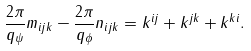<formula> <loc_0><loc_0><loc_500><loc_500>\frac { 2 \pi } { q _ { \psi } } m _ { i j k } - \frac { 2 \pi } { q _ { \phi } } n _ { i j k } = k ^ { i j } + k ^ { j k } + k ^ { k i } .</formula> 